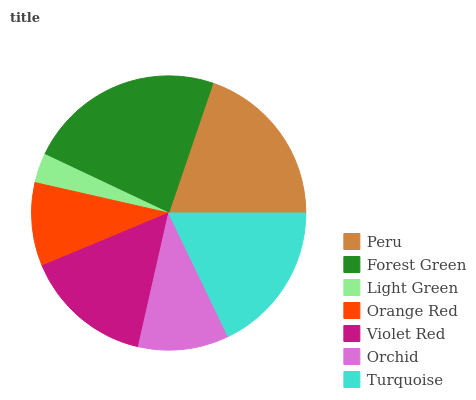Is Light Green the minimum?
Answer yes or no. Yes. Is Forest Green the maximum?
Answer yes or no. Yes. Is Forest Green the minimum?
Answer yes or no. No. Is Light Green the maximum?
Answer yes or no. No. Is Forest Green greater than Light Green?
Answer yes or no. Yes. Is Light Green less than Forest Green?
Answer yes or no. Yes. Is Light Green greater than Forest Green?
Answer yes or no. No. Is Forest Green less than Light Green?
Answer yes or no. No. Is Violet Red the high median?
Answer yes or no. Yes. Is Violet Red the low median?
Answer yes or no. Yes. Is Peru the high median?
Answer yes or no. No. Is Orchid the low median?
Answer yes or no. No. 